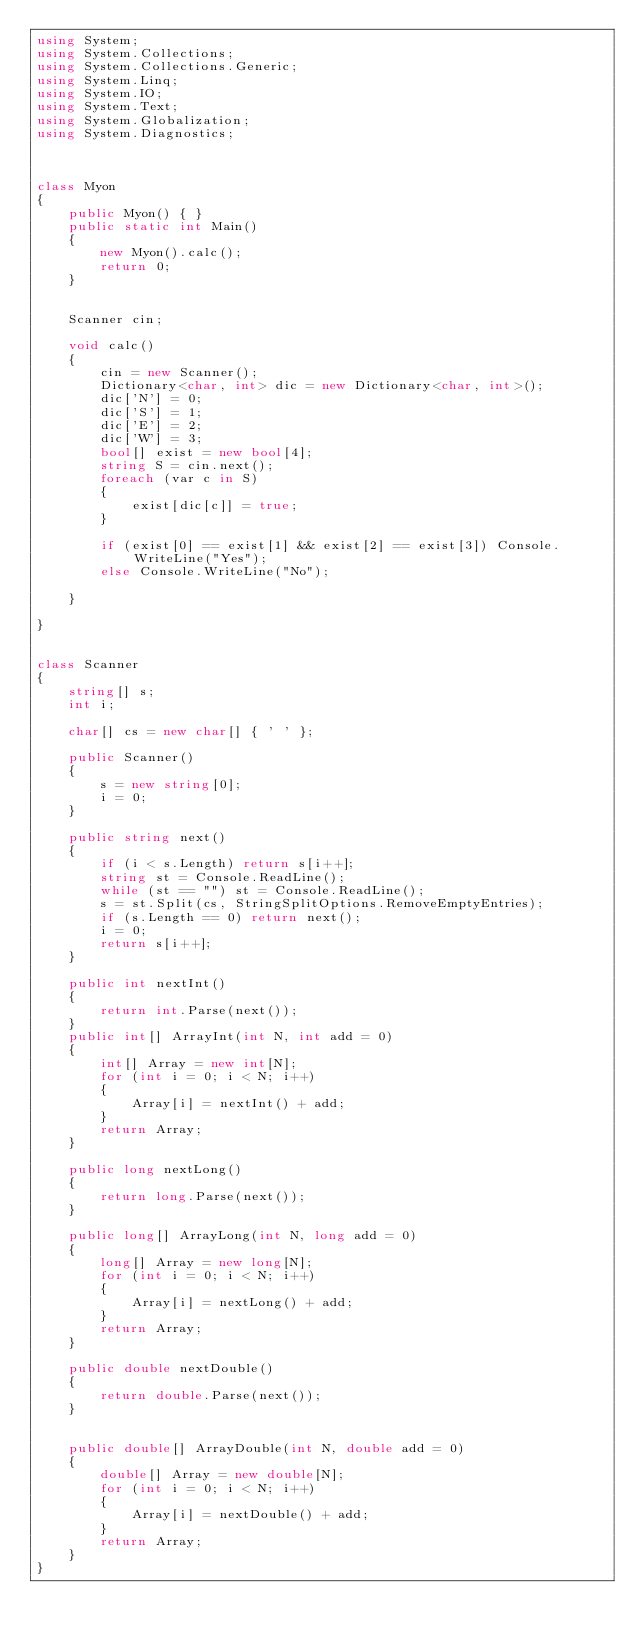<code> <loc_0><loc_0><loc_500><loc_500><_C#_>using System;
using System.Collections;
using System.Collections.Generic;
using System.Linq;
using System.IO;
using System.Text;
using System.Globalization;
using System.Diagnostics;



class Myon
{
    public Myon() { }
    public static int Main()
    {
        new Myon().calc();
        return 0;
    }


    Scanner cin;

    void calc()
    {
        cin = new Scanner();
        Dictionary<char, int> dic = new Dictionary<char, int>();
        dic['N'] = 0;
        dic['S'] = 1;
        dic['E'] = 2;
        dic['W'] = 3;
        bool[] exist = new bool[4];
        string S = cin.next();
        foreach (var c in S)
        {
            exist[dic[c]] = true;
        }

        if (exist[0] == exist[1] && exist[2] == exist[3]) Console.WriteLine("Yes");
        else Console.WriteLine("No");

    }

}


class Scanner
{
    string[] s;
    int i;

    char[] cs = new char[] { ' ' };

    public Scanner()
    {
        s = new string[0];
        i = 0;
    }

    public string next()
    {
        if (i < s.Length) return s[i++];
        string st = Console.ReadLine();
        while (st == "") st = Console.ReadLine();
        s = st.Split(cs, StringSplitOptions.RemoveEmptyEntries);
        if (s.Length == 0) return next();
        i = 0;
        return s[i++];
    }

    public int nextInt()
    {
        return int.Parse(next());
    }
    public int[] ArrayInt(int N, int add = 0)
    {
        int[] Array = new int[N];
        for (int i = 0; i < N; i++)
        {
            Array[i] = nextInt() + add;
        }
        return Array;
    }

    public long nextLong()
    {
        return long.Parse(next());
    }

    public long[] ArrayLong(int N, long add = 0)
    {
        long[] Array = new long[N];
        for (int i = 0; i < N; i++)
        {
            Array[i] = nextLong() + add;
        }
        return Array;
    }

    public double nextDouble()
    {
        return double.Parse(next());
    }


    public double[] ArrayDouble(int N, double add = 0)
    {
        double[] Array = new double[N];
        for (int i = 0; i < N; i++)
        {
            Array[i] = nextDouble() + add;
        }
        return Array;
    }
}
</code> 